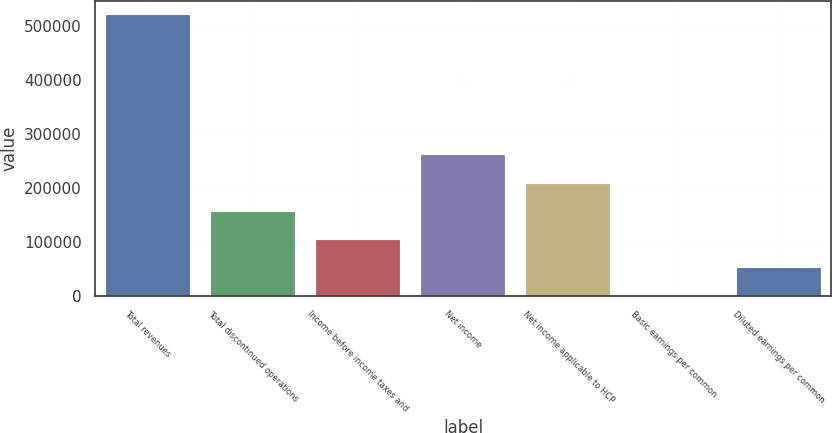Convert chart to OTSL. <chart><loc_0><loc_0><loc_500><loc_500><bar_chart><fcel>Total revenues<fcel>Total discontinued operations<fcel>Income before income taxes and<fcel>Net income<fcel>Net income applicable to HCP<fcel>Basic earnings per common<fcel>Diluted earnings per common<nl><fcel>520457<fcel>156137<fcel>104092<fcel>260229<fcel>208183<fcel>0.25<fcel>52045.9<nl></chart> 